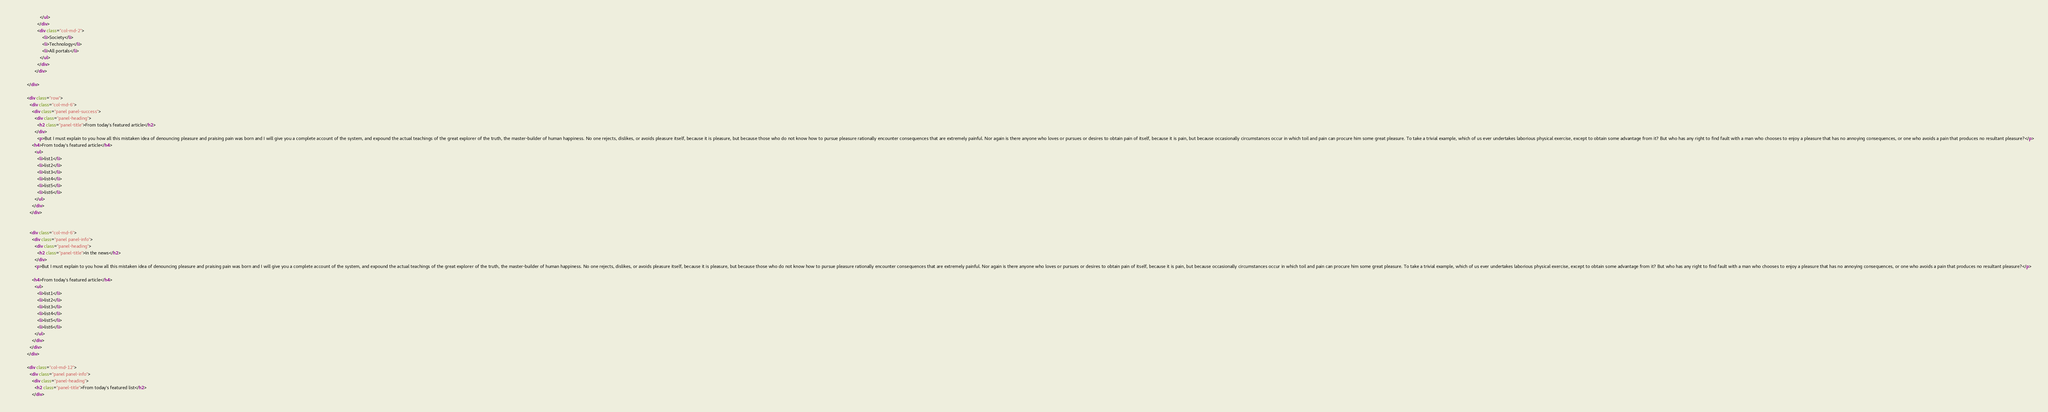Convert code to text. <code><loc_0><loc_0><loc_500><loc_500><_HTML_>                    </ul>
                  </div>
                  <div class="col-md-2">
                      <li>Society</li>
                      <li>Technology</li>
                      <li>All portals</li>
                    </ul>
                  </div>
                </div>

          </div>

          <div class="row">
            <div class="col-md-6">
              <div class="panel panel-success">
                <div class="panel-heading">
                  <h2 class="panel-title">From today's featured article</h2>
                </div>
                  <p>But I must explain to you how all this mistaken idea of denouncing pleasure and praising pain was born and I will give you a complete account of the system, and expound the actual teachings of the great explorer of the truth, the master-builder of human happiness. No one rejects, dislikes, or avoids pleasure itself, because it is pleasure, but because those who do not know how to pursue pleasure rationally encounter consequences that are extremely painful. Nor again is there anyone who loves or pursues or desires to obtain pain of itself, because it is pain, but because occasionally circumstances occur in which toil and pain can procure him some great pleasure. To take a trivial example, which of us ever undertakes laborious physical exercise, except to obtain some advantage from it? But who has any right to find fault with a man who chooses to enjoy a pleasure that has no annoying consequences, or one who avoids a pain that produces no resultant pleasure?</p>
              <h4>From today's featured article</h4>
                <ul>
                  <li>list1</li>
                  <li>list2</li>
                  <li>list3</li>
                  <li>list4</li>
                  <li>list5</li>
                  <li>list6</li>
                </ul>
              </div>
            </div>


            <div class="col-md-6">
              <div class="panel panel-info">
                <div class="panel-heading">
                  <h2 class="panel-title">In the news</h2>
                </div>
                <p>But I must explain to you how all this mistaken idea of denouncing pleasure and praising pain was born and I will give you a complete account of the system, and expound the actual teachings of the great explorer of the truth, the master-builder of human happiness. No one rejects, dislikes, or avoids pleasure itself, because it is pleasure, but because those who do not know how to pursue pleasure rationally encounter consequences that are extremely painful. Nor again is there anyone who loves or pursues or desires to obtain pain of itself, because it is pain, but because occasionally circumstances occur in which toil and pain can procure him some great pleasure. To take a trivial example, which of us ever undertakes laborious physical exercise, except to obtain some advantage from it? But who has any right to find fault with a man who chooses to enjoy a pleasure that has no annoying consequences, or one who avoids a pain that produces no resultant pleasure?</p>

              <h4>From today's featured article</h4>
                <ul>
                  <li>list1</li>
                  <li>list2</li>
                  <li>list3</li>
                  <li>list4</li>
                  <li>list5</li>
                  <li>list6</li>
                </ul>
              </div>
            </div>
          </div>

          <div class="col-md-12">
            <div class="panel panel-info">
              <div class="panel-heading">
                <h2 class="panel-title">From today's featured list</h2>
              </div></code> 